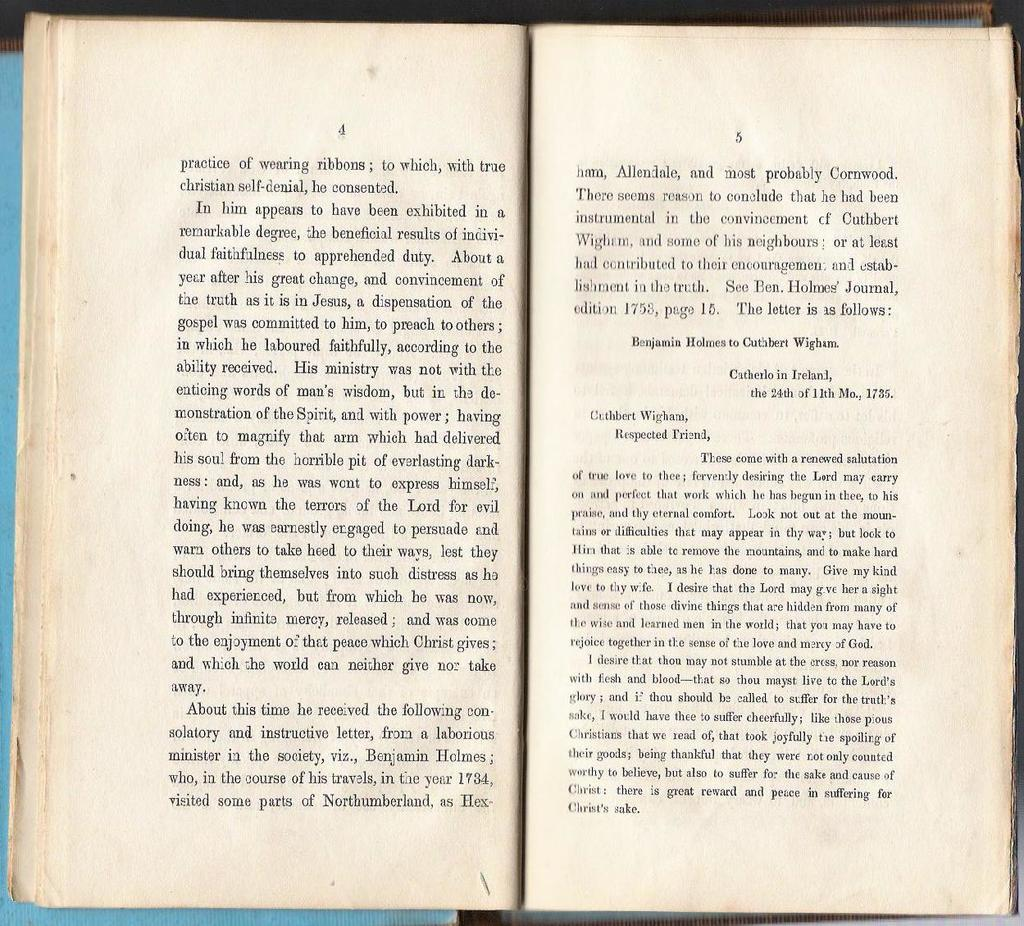Provide a one-sentence caption for the provided image. two pages of an open book with text written by cuthbert wigham. 